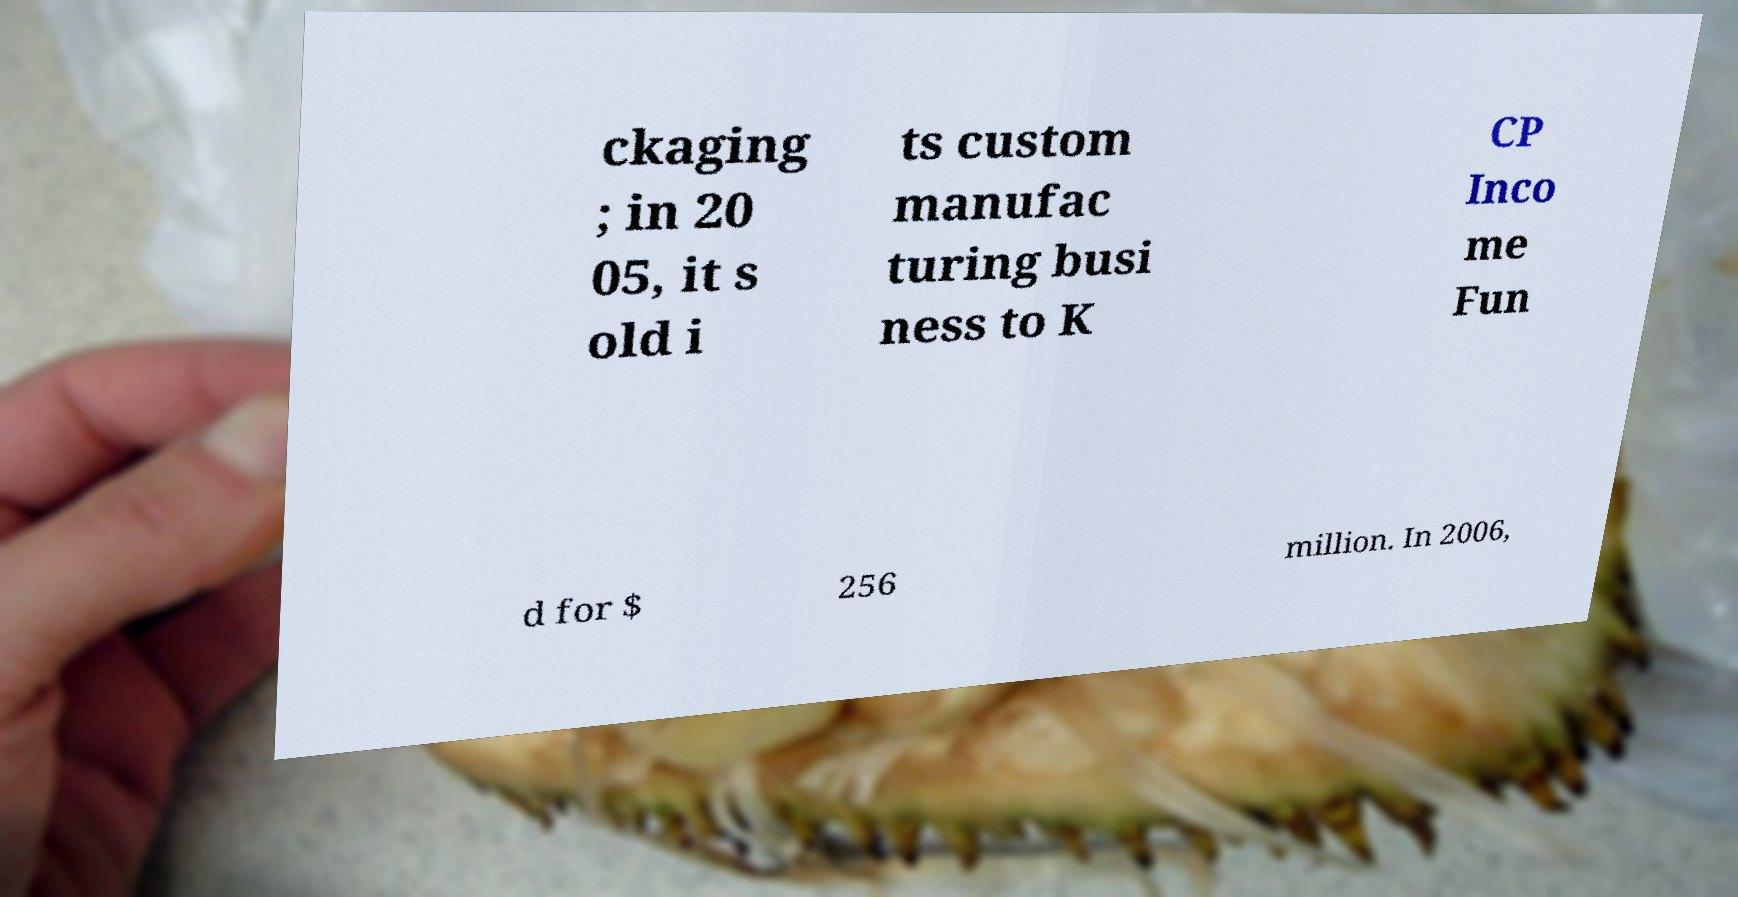Could you assist in decoding the text presented in this image and type it out clearly? ckaging ; in 20 05, it s old i ts custom manufac turing busi ness to K CP Inco me Fun d for $ 256 million. In 2006, 